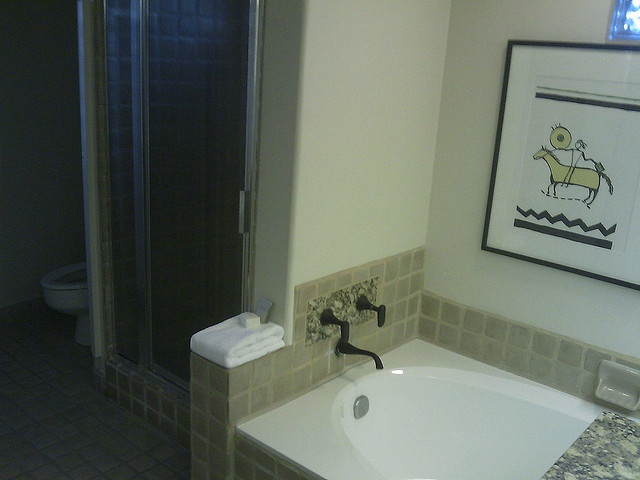Describe the objects in this image and their specific colors. I can see sink in black, darkgray, lightgray, and gray tones and toilet in black and purple tones in this image. 